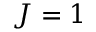Convert formula to latex. <formula><loc_0><loc_0><loc_500><loc_500>J = 1</formula> 